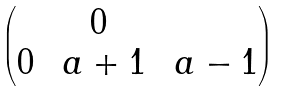<formula> <loc_0><loc_0><loc_500><loc_500>\begin{pmatrix} & 0 & \\ 0 & \ a + 1 & \ a - 1 \end{pmatrix}</formula> 